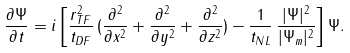Convert formula to latex. <formula><loc_0><loc_0><loc_500><loc_500>\frac { \partial \Psi } { \partial t } = i \left [ \frac { r _ { T F } ^ { 2 } } { t _ { D F } } \, ( \frac { \partial ^ { 2 } } { \partial x ^ { 2 } } + \frac { \partial ^ { 2 } } { \partial y ^ { 2 } } + \frac { \partial ^ { 2 } } { \partial z ^ { 2 } } ) - \frac { 1 } { t _ { N L } } \, \frac { | \Psi | ^ { 2 } } { | \Psi _ { m } | ^ { 2 } } \right ] \Psi .</formula> 